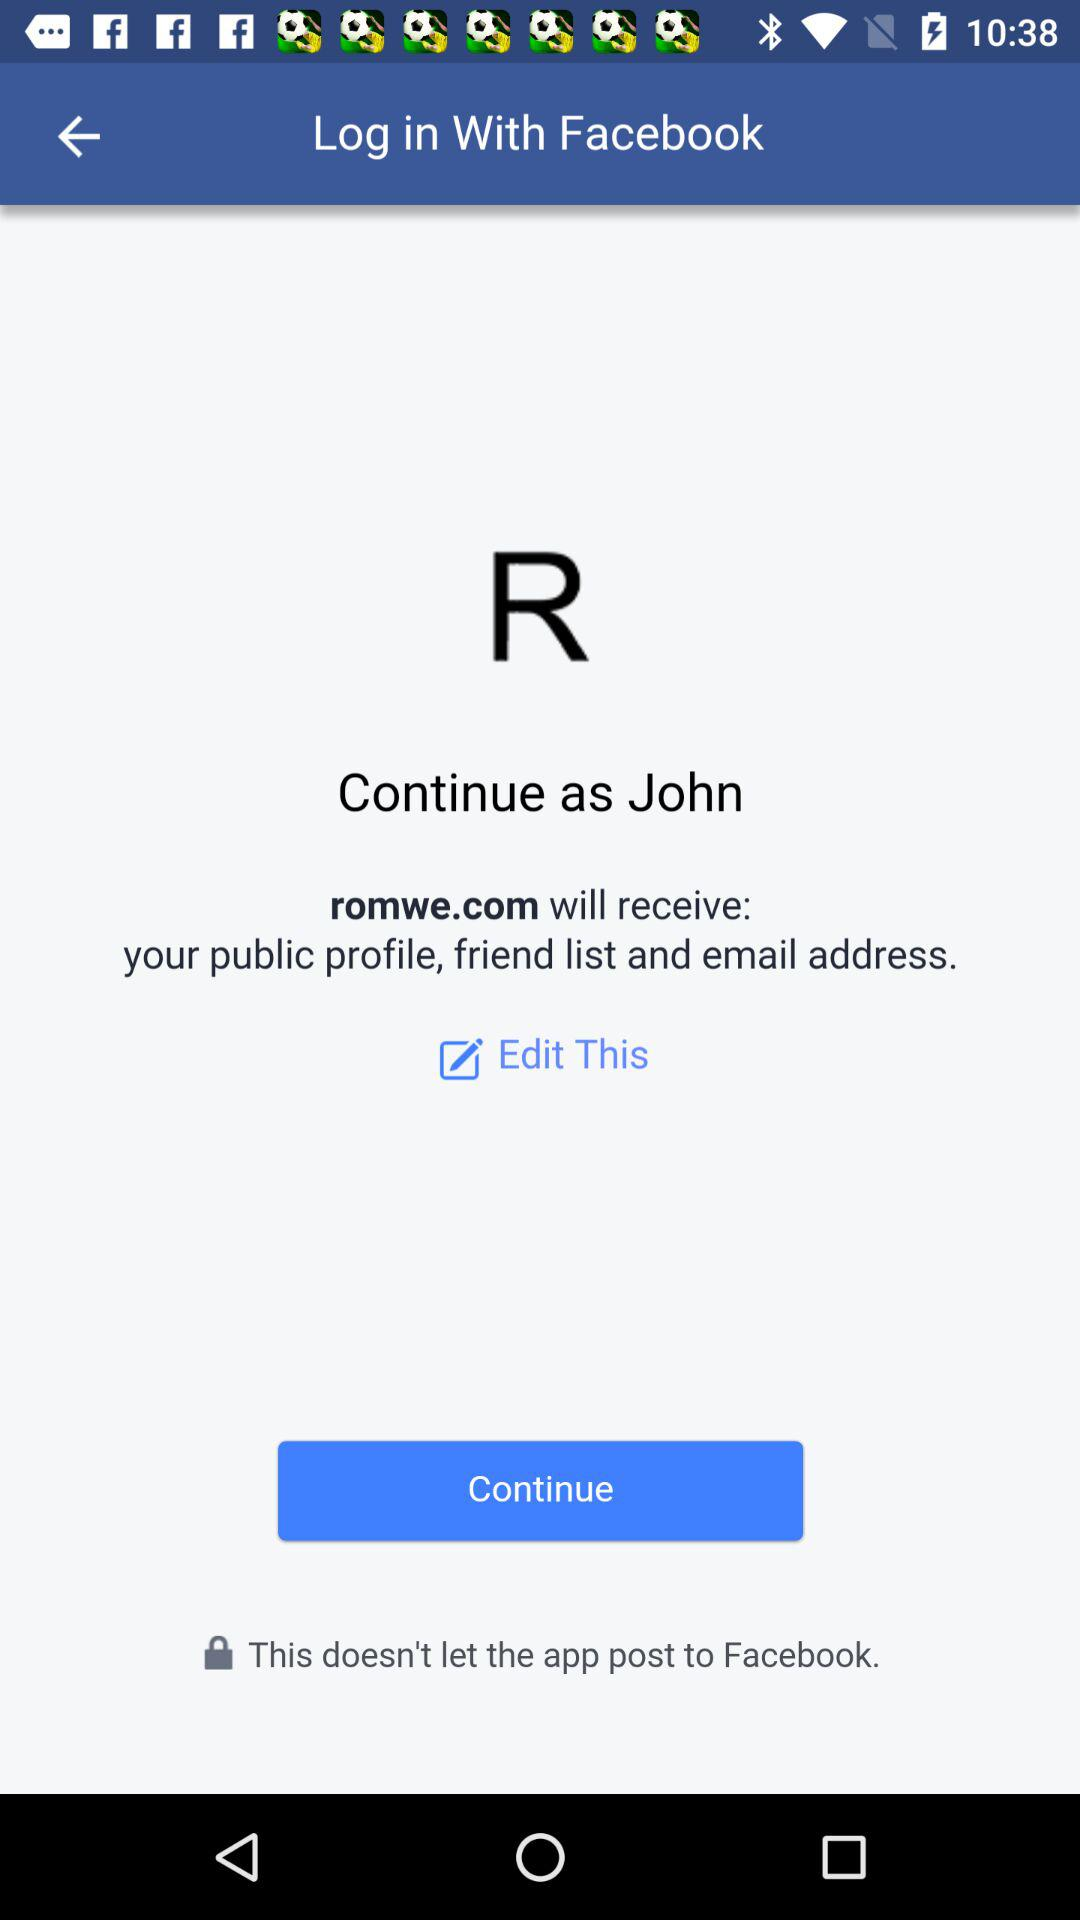What is the name of the user? The name of the user is John. 